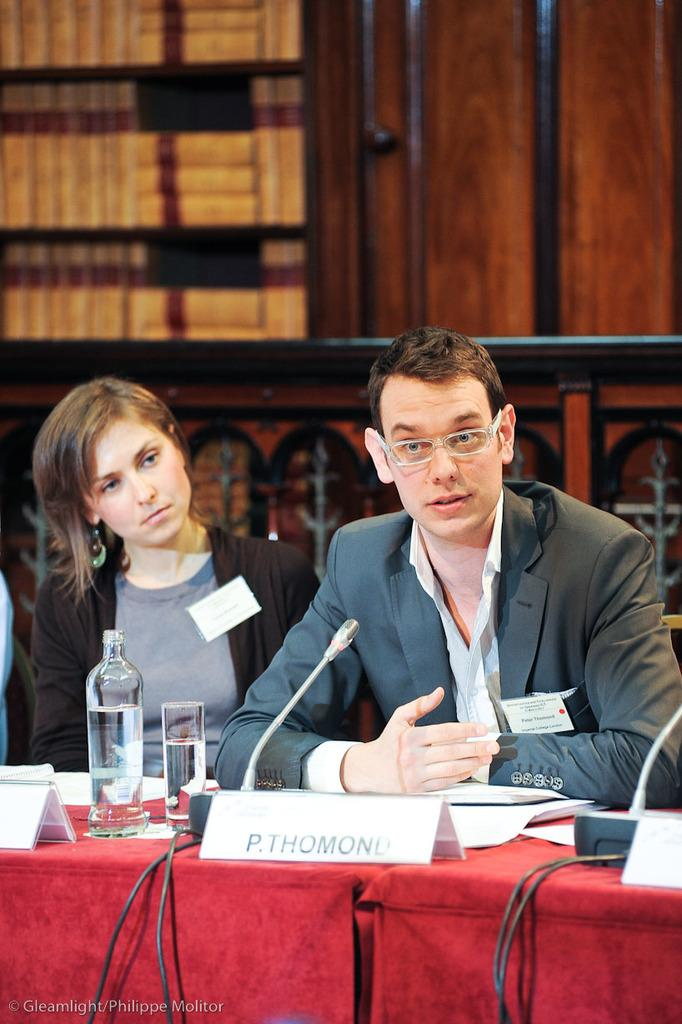How many people are in the image? There are two persons in the image. What are the persons doing in the image? The persons are sitting on chairs. What objects are in front of the persons? There is a microphone, a glass, and a water bottle in front of the persons. What can be seen in the background of the image? There are books visible in the background of the image. What type of prose is the woman reading in the image? There is no woman present in the image, and no one is reading any prose. 